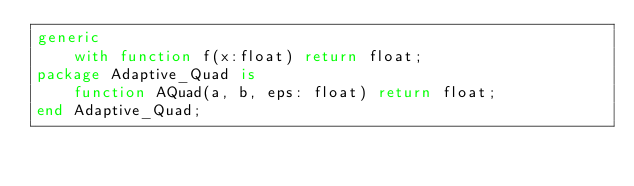<code> <loc_0><loc_0><loc_500><loc_500><_Ada_>generic
    with function f(x:float) return float;
package Adaptive_Quad is
    function AQuad(a, b, eps: float) return float;
end Adaptive_Quad; </code> 